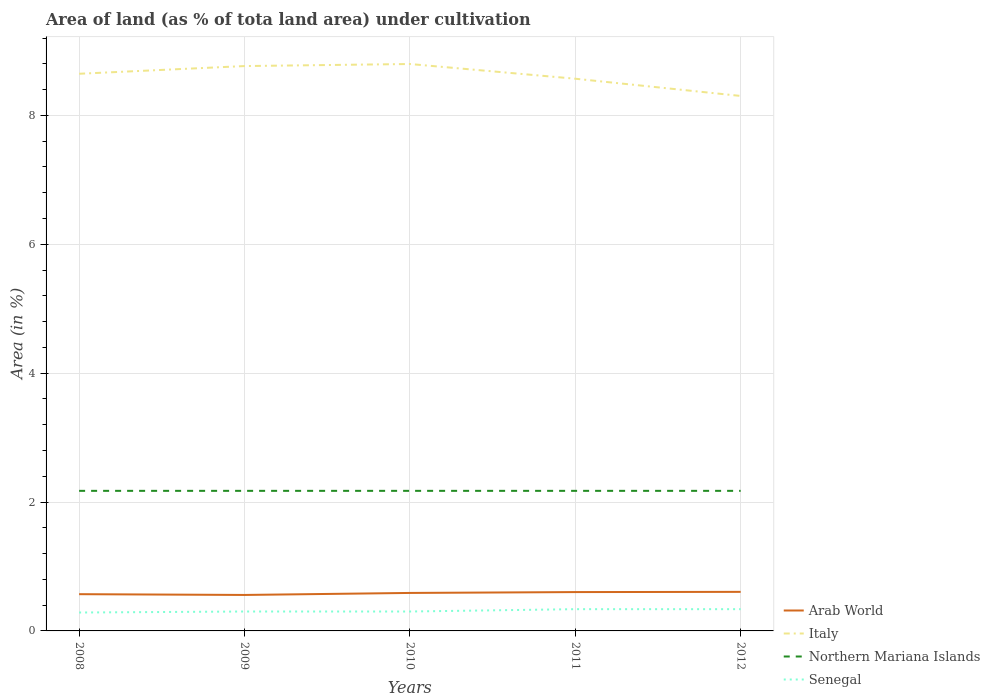How many different coloured lines are there?
Provide a short and direct response. 4. Does the line corresponding to Arab World intersect with the line corresponding to Senegal?
Offer a terse response. No. Is the number of lines equal to the number of legend labels?
Your answer should be very brief. Yes. Across all years, what is the maximum percentage of land under cultivation in Senegal?
Your answer should be very brief. 0.29. In which year was the percentage of land under cultivation in Northern Mariana Islands maximum?
Your answer should be compact. 2008. What is the total percentage of land under cultivation in Senegal in the graph?
Offer a very short reply. -0.02. What is the difference between the highest and the second highest percentage of land under cultivation in Italy?
Provide a succinct answer. 0.5. What is the difference between the highest and the lowest percentage of land under cultivation in Senegal?
Offer a very short reply. 2. Are the values on the major ticks of Y-axis written in scientific E-notation?
Make the answer very short. No. Where does the legend appear in the graph?
Make the answer very short. Bottom right. How are the legend labels stacked?
Offer a very short reply. Vertical. What is the title of the graph?
Keep it short and to the point. Area of land (as % of tota land area) under cultivation. Does "Nigeria" appear as one of the legend labels in the graph?
Keep it short and to the point. No. What is the label or title of the Y-axis?
Keep it short and to the point. Area (in %). What is the Area (in %) in Arab World in 2008?
Provide a succinct answer. 0.57. What is the Area (in %) in Italy in 2008?
Offer a terse response. 8.65. What is the Area (in %) of Northern Mariana Islands in 2008?
Keep it short and to the point. 2.17. What is the Area (in %) of Senegal in 2008?
Provide a short and direct response. 0.29. What is the Area (in %) in Arab World in 2009?
Offer a very short reply. 0.56. What is the Area (in %) in Italy in 2009?
Your response must be concise. 8.77. What is the Area (in %) in Northern Mariana Islands in 2009?
Ensure brevity in your answer.  2.17. What is the Area (in %) of Senegal in 2009?
Offer a very short reply. 0.3. What is the Area (in %) in Arab World in 2010?
Offer a very short reply. 0.59. What is the Area (in %) of Italy in 2010?
Offer a terse response. 8.8. What is the Area (in %) of Northern Mariana Islands in 2010?
Keep it short and to the point. 2.17. What is the Area (in %) of Senegal in 2010?
Provide a succinct answer. 0.3. What is the Area (in %) in Arab World in 2011?
Provide a succinct answer. 0.6. What is the Area (in %) in Italy in 2011?
Your answer should be compact. 8.57. What is the Area (in %) of Northern Mariana Islands in 2011?
Provide a succinct answer. 2.17. What is the Area (in %) in Senegal in 2011?
Your answer should be compact. 0.34. What is the Area (in %) of Arab World in 2012?
Ensure brevity in your answer.  0.61. What is the Area (in %) in Italy in 2012?
Provide a succinct answer. 8.3. What is the Area (in %) in Northern Mariana Islands in 2012?
Your answer should be compact. 2.17. What is the Area (in %) in Senegal in 2012?
Provide a succinct answer. 0.34. Across all years, what is the maximum Area (in %) in Arab World?
Ensure brevity in your answer.  0.61. Across all years, what is the maximum Area (in %) of Italy?
Provide a succinct answer. 8.8. Across all years, what is the maximum Area (in %) in Northern Mariana Islands?
Your response must be concise. 2.17. Across all years, what is the maximum Area (in %) in Senegal?
Your response must be concise. 0.34. Across all years, what is the minimum Area (in %) of Arab World?
Your answer should be compact. 0.56. Across all years, what is the minimum Area (in %) of Italy?
Offer a terse response. 8.3. Across all years, what is the minimum Area (in %) of Northern Mariana Islands?
Your answer should be compact. 2.17. Across all years, what is the minimum Area (in %) in Senegal?
Make the answer very short. 0.29. What is the total Area (in %) in Arab World in the graph?
Keep it short and to the point. 2.93. What is the total Area (in %) in Italy in the graph?
Ensure brevity in your answer.  43.08. What is the total Area (in %) in Northern Mariana Islands in the graph?
Offer a terse response. 10.87. What is the total Area (in %) in Senegal in the graph?
Provide a short and direct response. 1.56. What is the difference between the Area (in %) of Arab World in 2008 and that in 2009?
Make the answer very short. 0.01. What is the difference between the Area (in %) of Italy in 2008 and that in 2009?
Provide a succinct answer. -0.12. What is the difference between the Area (in %) of Senegal in 2008 and that in 2009?
Offer a very short reply. -0.02. What is the difference between the Area (in %) of Arab World in 2008 and that in 2010?
Your answer should be compact. -0.02. What is the difference between the Area (in %) in Italy in 2008 and that in 2010?
Offer a very short reply. -0.15. What is the difference between the Area (in %) in Senegal in 2008 and that in 2010?
Keep it short and to the point. -0.02. What is the difference between the Area (in %) of Arab World in 2008 and that in 2011?
Offer a terse response. -0.03. What is the difference between the Area (in %) in Italy in 2008 and that in 2011?
Offer a terse response. 0.08. What is the difference between the Area (in %) in Northern Mariana Islands in 2008 and that in 2011?
Provide a short and direct response. 0. What is the difference between the Area (in %) in Senegal in 2008 and that in 2011?
Ensure brevity in your answer.  -0.05. What is the difference between the Area (in %) in Arab World in 2008 and that in 2012?
Ensure brevity in your answer.  -0.04. What is the difference between the Area (in %) of Italy in 2008 and that in 2012?
Make the answer very short. 0.34. What is the difference between the Area (in %) of Northern Mariana Islands in 2008 and that in 2012?
Your answer should be compact. 0. What is the difference between the Area (in %) of Senegal in 2008 and that in 2012?
Provide a succinct answer. -0.05. What is the difference between the Area (in %) of Arab World in 2009 and that in 2010?
Make the answer very short. -0.03. What is the difference between the Area (in %) of Italy in 2009 and that in 2010?
Your answer should be compact. -0.03. What is the difference between the Area (in %) in Northern Mariana Islands in 2009 and that in 2010?
Give a very brief answer. 0. What is the difference between the Area (in %) in Senegal in 2009 and that in 2010?
Your response must be concise. 0. What is the difference between the Area (in %) in Arab World in 2009 and that in 2011?
Offer a terse response. -0.04. What is the difference between the Area (in %) in Italy in 2009 and that in 2011?
Offer a terse response. 0.2. What is the difference between the Area (in %) in Senegal in 2009 and that in 2011?
Keep it short and to the point. -0.04. What is the difference between the Area (in %) of Arab World in 2009 and that in 2012?
Provide a short and direct response. -0.05. What is the difference between the Area (in %) of Italy in 2009 and that in 2012?
Your answer should be compact. 0.46. What is the difference between the Area (in %) in Northern Mariana Islands in 2009 and that in 2012?
Offer a terse response. 0. What is the difference between the Area (in %) in Senegal in 2009 and that in 2012?
Provide a short and direct response. -0.04. What is the difference between the Area (in %) in Arab World in 2010 and that in 2011?
Provide a short and direct response. -0.01. What is the difference between the Area (in %) in Italy in 2010 and that in 2011?
Your response must be concise. 0.23. What is the difference between the Area (in %) in Senegal in 2010 and that in 2011?
Make the answer very short. -0.04. What is the difference between the Area (in %) of Arab World in 2010 and that in 2012?
Offer a terse response. -0.02. What is the difference between the Area (in %) of Italy in 2010 and that in 2012?
Ensure brevity in your answer.  0.5. What is the difference between the Area (in %) of Northern Mariana Islands in 2010 and that in 2012?
Offer a very short reply. 0. What is the difference between the Area (in %) of Senegal in 2010 and that in 2012?
Offer a terse response. -0.04. What is the difference between the Area (in %) in Arab World in 2011 and that in 2012?
Your answer should be very brief. -0. What is the difference between the Area (in %) of Italy in 2011 and that in 2012?
Your answer should be compact. 0.27. What is the difference between the Area (in %) of Senegal in 2011 and that in 2012?
Give a very brief answer. 0. What is the difference between the Area (in %) of Arab World in 2008 and the Area (in %) of Italy in 2009?
Ensure brevity in your answer.  -8.2. What is the difference between the Area (in %) in Arab World in 2008 and the Area (in %) in Northern Mariana Islands in 2009?
Offer a very short reply. -1.6. What is the difference between the Area (in %) in Arab World in 2008 and the Area (in %) in Senegal in 2009?
Offer a very short reply. 0.27. What is the difference between the Area (in %) of Italy in 2008 and the Area (in %) of Northern Mariana Islands in 2009?
Your answer should be compact. 6.47. What is the difference between the Area (in %) in Italy in 2008 and the Area (in %) in Senegal in 2009?
Provide a succinct answer. 8.35. What is the difference between the Area (in %) in Northern Mariana Islands in 2008 and the Area (in %) in Senegal in 2009?
Your answer should be compact. 1.87. What is the difference between the Area (in %) in Arab World in 2008 and the Area (in %) in Italy in 2010?
Make the answer very short. -8.23. What is the difference between the Area (in %) in Arab World in 2008 and the Area (in %) in Northern Mariana Islands in 2010?
Offer a very short reply. -1.6. What is the difference between the Area (in %) of Arab World in 2008 and the Area (in %) of Senegal in 2010?
Make the answer very short. 0.27. What is the difference between the Area (in %) in Italy in 2008 and the Area (in %) in Northern Mariana Islands in 2010?
Offer a terse response. 6.47. What is the difference between the Area (in %) of Italy in 2008 and the Area (in %) of Senegal in 2010?
Your response must be concise. 8.35. What is the difference between the Area (in %) in Northern Mariana Islands in 2008 and the Area (in %) in Senegal in 2010?
Make the answer very short. 1.87. What is the difference between the Area (in %) in Arab World in 2008 and the Area (in %) in Italy in 2011?
Your response must be concise. -8. What is the difference between the Area (in %) in Arab World in 2008 and the Area (in %) in Northern Mariana Islands in 2011?
Your response must be concise. -1.6. What is the difference between the Area (in %) in Arab World in 2008 and the Area (in %) in Senegal in 2011?
Your answer should be compact. 0.23. What is the difference between the Area (in %) in Italy in 2008 and the Area (in %) in Northern Mariana Islands in 2011?
Ensure brevity in your answer.  6.47. What is the difference between the Area (in %) of Italy in 2008 and the Area (in %) of Senegal in 2011?
Give a very brief answer. 8.31. What is the difference between the Area (in %) in Northern Mariana Islands in 2008 and the Area (in %) in Senegal in 2011?
Your answer should be very brief. 1.84. What is the difference between the Area (in %) in Arab World in 2008 and the Area (in %) in Italy in 2012?
Your answer should be compact. -7.73. What is the difference between the Area (in %) in Arab World in 2008 and the Area (in %) in Northern Mariana Islands in 2012?
Keep it short and to the point. -1.6. What is the difference between the Area (in %) of Arab World in 2008 and the Area (in %) of Senegal in 2012?
Offer a terse response. 0.23. What is the difference between the Area (in %) in Italy in 2008 and the Area (in %) in Northern Mariana Islands in 2012?
Provide a short and direct response. 6.47. What is the difference between the Area (in %) of Italy in 2008 and the Area (in %) of Senegal in 2012?
Keep it short and to the point. 8.31. What is the difference between the Area (in %) of Northern Mariana Islands in 2008 and the Area (in %) of Senegal in 2012?
Provide a short and direct response. 1.84. What is the difference between the Area (in %) of Arab World in 2009 and the Area (in %) of Italy in 2010?
Your answer should be very brief. -8.24. What is the difference between the Area (in %) of Arab World in 2009 and the Area (in %) of Northern Mariana Islands in 2010?
Give a very brief answer. -1.62. What is the difference between the Area (in %) in Arab World in 2009 and the Area (in %) in Senegal in 2010?
Offer a very short reply. 0.26. What is the difference between the Area (in %) of Italy in 2009 and the Area (in %) of Northern Mariana Islands in 2010?
Offer a very short reply. 6.59. What is the difference between the Area (in %) in Italy in 2009 and the Area (in %) in Senegal in 2010?
Make the answer very short. 8.46. What is the difference between the Area (in %) of Northern Mariana Islands in 2009 and the Area (in %) of Senegal in 2010?
Your answer should be very brief. 1.87. What is the difference between the Area (in %) in Arab World in 2009 and the Area (in %) in Italy in 2011?
Offer a very short reply. -8.01. What is the difference between the Area (in %) in Arab World in 2009 and the Area (in %) in Northern Mariana Islands in 2011?
Give a very brief answer. -1.62. What is the difference between the Area (in %) of Arab World in 2009 and the Area (in %) of Senegal in 2011?
Make the answer very short. 0.22. What is the difference between the Area (in %) of Italy in 2009 and the Area (in %) of Northern Mariana Islands in 2011?
Your answer should be very brief. 6.59. What is the difference between the Area (in %) in Italy in 2009 and the Area (in %) in Senegal in 2011?
Provide a succinct answer. 8.43. What is the difference between the Area (in %) in Northern Mariana Islands in 2009 and the Area (in %) in Senegal in 2011?
Offer a very short reply. 1.84. What is the difference between the Area (in %) in Arab World in 2009 and the Area (in %) in Italy in 2012?
Your answer should be very brief. -7.74. What is the difference between the Area (in %) in Arab World in 2009 and the Area (in %) in Northern Mariana Islands in 2012?
Provide a succinct answer. -1.62. What is the difference between the Area (in %) in Arab World in 2009 and the Area (in %) in Senegal in 2012?
Provide a short and direct response. 0.22. What is the difference between the Area (in %) in Italy in 2009 and the Area (in %) in Northern Mariana Islands in 2012?
Your answer should be compact. 6.59. What is the difference between the Area (in %) of Italy in 2009 and the Area (in %) of Senegal in 2012?
Your answer should be very brief. 8.43. What is the difference between the Area (in %) in Northern Mariana Islands in 2009 and the Area (in %) in Senegal in 2012?
Your answer should be compact. 1.84. What is the difference between the Area (in %) in Arab World in 2010 and the Area (in %) in Italy in 2011?
Your answer should be compact. -7.98. What is the difference between the Area (in %) of Arab World in 2010 and the Area (in %) of Northern Mariana Islands in 2011?
Your answer should be very brief. -1.58. What is the difference between the Area (in %) of Arab World in 2010 and the Area (in %) of Senegal in 2011?
Your answer should be compact. 0.25. What is the difference between the Area (in %) in Italy in 2010 and the Area (in %) in Northern Mariana Islands in 2011?
Keep it short and to the point. 6.62. What is the difference between the Area (in %) of Italy in 2010 and the Area (in %) of Senegal in 2011?
Provide a short and direct response. 8.46. What is the difference between the Area (in %) in Northern Mariana Islands in 2010 and the Area (in %) in Senegal in 2011?
Give a very brief answer. 1.84. What is the difference between the Area (in %) of Arab World in 2010 and the Area (in %) of Italy in 2012?
Offer a terse response. -7.71. What is the difference between the Area (in %) of Arab World in 2010 and the Area (in %) of Northern Mariana Islands in 2012?
Your response must be concise. -1.58. What is the difference between the Area (in %) in Arab World in 2010 and the Area (in %) in Senegal in 2012?
Offer a terse response. 0.25. What is the difference between the Area (in %) of Italy in 2010 and the Area (in %) of Northern Mariana Islands in 2012?
Give a very brief answer. 6.62. What is the difference between the Area (in %) of Italy in 2010 and the Area (in %) of Senegal in 2012?
Ensure brevity in your answer.  8.46. What is the difference between the Area (in %) in Northern Mariana Islands in 2010 and the Area (in %) in Senegal in 2012?
Offer a very short reply. 1.84. What is the difference between the Area (in %) of Arab World in 2011 and the Area (in %) of Italy in 2012?
Your answer should be compact. -7.7. What is the difference between the Area (in %) of Arab World in 2011 and the Area (in %) of Northern Mariana Islands in 2012?
Provide a succinct answer. -1.57. What is the difference between the Area (in %) of Arab World in 2011 and the Area (in %) of Senegal in 2012?
Your answer should be compact. 0.27. What is the difference between the Area (in %) in Italy in 2011 and the Area (in %) in Northern Mariana Islands in 2012?
Keep it short and to the point. 6.4. What is the difference between the Area (in %) in Italy in 2011 and the Area (in %) in Senegal in 2012?
Your answer should be very brief. 8.23. What is the difference between the Area (in %) in Northern Mariana Islands in 2011 and the Area (in %) in Senegal in 2012?
Your answer should be compact. 1.84. What is the average Area (in %) in Arab World per year?
Your response must be concise. 0.59. What is the average Area (in %) of Italy per year?
Ensure brevity in your answer.  8.62. What is the average Area (in %) of Northern Mariana Islands per year?
Ensure brevity in your answer.  2.17. What is the average Area (in %) in Senegal per year?
Ensure brevity in your answer.  0.31. In the year 2008, what is the difference between the Area (in %) of Arab World and Area (in %) of Italy?
Ensure brevity in your answer.  -8.08. In the year 2008, what is the difference between the Area (in %) of Arab World and Area (in %) of Northern Mariana Islands?
Keep it short and to the point. -1.6. In the year 2008, what is the difference between the Area (in %) in Arab World and Area (in %) in Senegal?
Ensure brevity in your answer.  0.28. In the year 2008, what is the difference between the Area (in %) in Italy and Area (in %) in Northern Mariana Islands?
Your answer should be compact. 6.47. In the year 2008, what is the difference between the Area (in %) of Italy and Area (in %) of Senegal?
Give a very brief answer. 8.36. In the year 2008, what is the difference between the Area (in %) of Northern Mariana Islands and Area (in %) of Senegal?
Give a very brief answer. 1.89. In the year 2009, what is the difference between the Area (in %) of Arab World and Area (in %) of Italy?
Your response must be concise. -8.21. In the year 2009, what is the difference between the Area (in %) of Arab World and Area (in %) of Northern Mariana Islands?
Offer a terse response. -1.62. In the year 2009, what is the difference between the Area (in %) of Arab World and Area (in %) of Senegal?
Your response must be concise. 0.26. In the year 2009, what is the difference between the Area (in %) of Italy and Area (in %) of Northern Mariana Islands?
Your answer should be compact. 6.59. In the year 2009, what is the difference between the Area (in %) of Italy and Area (in %) of Senegal?
Provide a succinct answer. 8.46. In the year 2009, what is the difference between the Area (in %) in Northern Mariana Islands and Area (in %) in Senegal?
Offer a very short reply. 1.87. In the year 2010, what is the difference between the Area (in %) of Arab World and Area (in %) of Italy?
Your answer should be compact. -8.21. In the year 2010, what is the difference between the Area (in %) of Arab World and Area (in %) of Northern Mariana Islands?
Offer a terse response. -1.58. In the year 2010, what is the difference between the Area (in %) of Arab World and Area (in %) of Senegal?
Your answer should be very brief. 0.29. In the year 2010, what is the difference between the Area (in %) of Italy and Area (in %) of Northern Mariana Islands?
Offer a terse response. 6.62. In the year 2010, what is the difference between the Area (in %) of Italy and Area (in %) of Senegal?
Give a very brief answer. 8.5. In the year 2010, what is the difference between the Area (in %) in Northern Mariana Islands and Area (in %) in Senegal?
Your answer should be compact. 1.87. In the year 2011, what is the difference between the Area (in %) of Arab World and Area (in %) of Italy?
Ensure brevity in your answer.  -7.97. In the year 2011, what is the difference between the Area (in %) of Arab World and Area (in %) of Northern Mariana Islands?
Make the answer very short. -1.57. In the year 2011, what is the difference between the Area (in %) of Arab World and Area (in %) of Senegal?
Keep it short and to the point. 0.27. In the year 2011, what is the difference between the Area (in %) in Italy and Area (in %) in Northern Mariana Islands?
Your response must be concise. 6.4. In the year 2011, what is the difference between the Area (in %) of Italy and Area (in %) of Senegal?
Your answer should be very brief. 8.23. In the year 2011, what is the difference between the Area (in %) of Northern Mariana Islands and Area (in %) of Senegal?
Give a very brief answer. 1.84. In the year 2012, what is the difference between the Area (in %) in Arab World and Area (in %) in Italy?
Offer a very short reply. -7.7. In the year 2012, what is the difference between the Area (in %) in Arab World and Area (in %) in Northern Mariana Islands?
Your answer should be compact. -1.57. In the year 2012, what is the difference between the Area (in %) of Arab World and Area (in %) of Senegal?
Your answer should be very brief. 0.27. In the year 2012, what is the difference between the Area (in %) in Italy and Area (in %) in Northern Mariana Islands?
Offer a very short reply. 6.13. In the year 2012, what is the difference between the Area (in %) in Italy and Area (in %) in Senegal?
Offer a very short reply. 7.96. In the year 2012, what is the difference between the Area (in %) in Northern Mariana Islands and Area (in %) in Senegal?
Your answer should be very brief. 1.84. What is the ratio of the Area (in %) of Arab World in 2008 to that in 2009?
Offer a terse response. 1.02. What is the ratio of the Area (in %) in Italy in 2008 to that in 2009?
Offer a terse response. 0.99. What is the ratio of the Area (in %) of Northern Mariana Islands in 2008 to that in 2009?
Offer a terse response. 1. What is the ratio of the Area (in %) of Senegal in 2008 to that in 2009?
Make the answer very short. 0.95. What is the ratio of the Area (in %) of Arab World in 2008 to that in 2010?
Offer a very short reply. 0.97. What is the ratio of the Area (in %) in Italy in 2008 to that in 2010?
Your response must be concise. 0.98. What is the ratio of the Area (in %) of Northern Mariana Islands in 2008 to that in 2010?
Your answer should be compact. 1. What is the ratio of the Area (in %) in Senegal in 2008 to that in 2010?
Your answer should be compact. 0.95. What is the ratio of the Area (in %) in Arab World in 2008 to that in 2011?
Your answer should be compact. 0.95. What is the ratio of the Area (in %) of Italy in 2008 to that in 2011?
Give a very brief answer. 1.01. What is the ratio of the Area (in %) of Northern Mariana Islands in 2008 to that in 2011?
Your response must be concise. 1. What is the ratio of the Area (in %) in Senegal in 2008 to that in 2011?
Provide a succinct answer. 0.85. What is the ratio of the Area (in %) of Arab World in 2008 to that in 2012?
Provide a succinct answer. 0.94. What is the ratio of the Area (in %) of Italy in 2008 to that in 2012?
Your answer should be compact. 1.04. What is the ratio of the Area (in %) of Senegal in 2008 to that in 2012?
Offer a very short reply. 0.85. What is the ratio of the Area (in %) of Arab World in 2009 to that in 2010?
Your response must be concise. 0.95. What is the ratio of the Area (in %) of Italy in 2009 to that in 2010?
Make the answer very short. 1. What is the ratio of the Area (in %) in Northern Mariana Islands in 2009 to that in 2010?
Ensure brevity in your answer.  1. What is the ratio of the Area (in %) of Senegal in 2009 to that in 2010?
Keep it short and to the point. 1. What is the ratio of the Area (in %) of Arab World in 2009 to that in 2011?
Ensure brevity in your answer.  0.93. What is the ratio of the Area (in %) of Italy in 2009 to that in 2011?
Your response must be concise. 1.02. What is the ratio of the Area (in %) of Northern Mariana Islands in 2009 to that in 2011?
Your response must be concise. 1. What is the ratio of the Area (in %) of Senegal in 2009 to that in 2011?
Offer a terse response. 0.89. What is the ratio of the Area (in %) of Arab World in 2009 to that in 2012?
Provide a succinct answer. 0.92. What is the ratio of the Area (in %) of Italy in 2009 to that in 2012?
Provide a short and direct response. 1.06. What is the ratio of the Area (in %) in Northern Mariana Islands in 2009 to that in 2012?
Make the answer very short. 1. What is the ratio of the Area (in %) of Senegal in 2009 to that in 2012?
Make the answer very short. 0.89. What is the ratio of the Area (in %) of Arab World in 2010 to that in 2011?
Provide a short and direct response. 0.98. What is the ratio of the Area (in %) in Italy in 2010 to that in 2011?
Your answer should be compact. 1.03. What is the ratio of the Area (in %) of Northern Mariana Islands in 2010 to that in 2011?
Offer a very short reply. 1. What is the ratio of the Area (in %) of Senegal in 2010 to that in 2011?
Ensure brevity in your answer.  0.89. What is the ratio of the Area (in %) in Arab World in 2010 to that in 2012?
Provide a short and direct response. 0.97. What is the ratio of the Area (in %) of Italy in 2010 to that in 2012?
Make the answer very short. 1.06. What is the ratio of the Area (in %) of Senegal in 2010 to that in 2012?
Provide a succinct answer. 0.89. What is the ratio of the Area (in %) in Italy in 2011 to that in 2012?
Provide a succinct answer. 1.03. What is the ratio of the Area (in %) of Northern Mariana Islands in 2011 to that in 2012?
Offer a very short reply. 1. What is the difference between the highest and the second highest Area (in %) in Arab World?
Offer a very short reply. 0. What is the difference between the highest and the second highest Area (in %) of Italy?
Your answer should be very brief. 0.03. What is the difference between the highest and the lowest Area (in %) in Arab World?
Keep it short and to the point. 0.05. What is the difference between the highest and the lowest Area (in %) in Italy?
Offer a very short reply. 0.5. What is the difference between the highest and the lowest Area (in %) of Senegal?
Give a very brief answer. 0.05. 